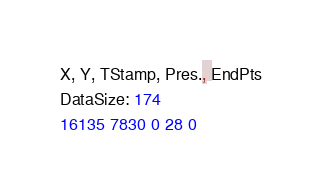Convert code to text. <code><loc_0><loc_0><loc_500><loc_500><_SML_>X, Y, TStamp, Pres., EndPts
DataSize: 174
16135 7830 0 28 0</code> 